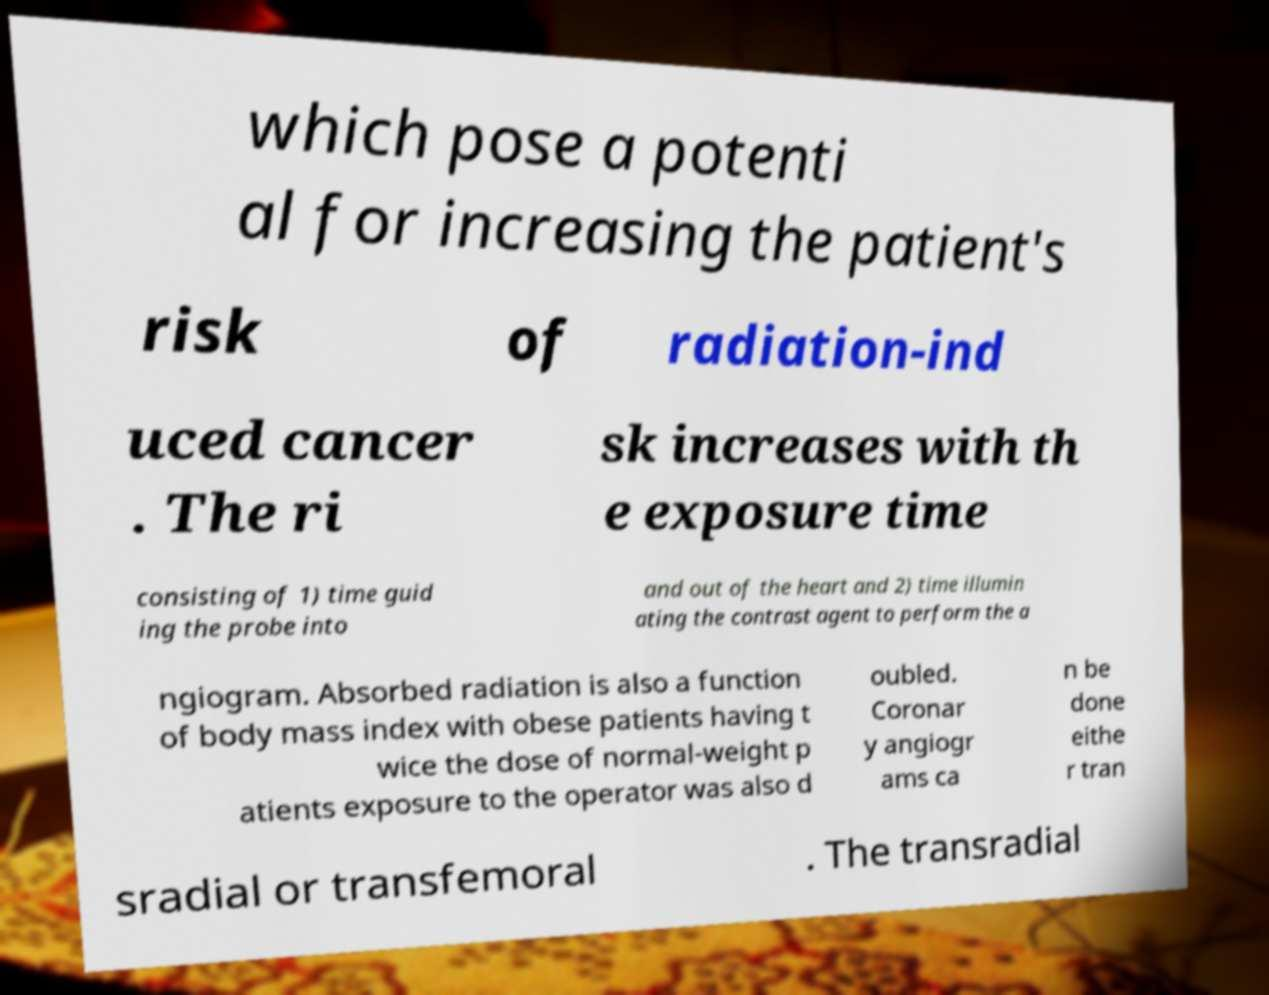What messages or text are displayed in this image? I need them in a readable, typed format. which pose a potenti al for increasing the patient's risk of radiation-ind uced cancer . The ri sk increases with th e exposure time consisting of 1) time guid ing the probe into and out of the heart and 2) time illumin ating the contrast agent to perform the a ngiogram. Absorbed radiation is also a function of body mass index with obese patients having t wice the dose of normal-weight p atients exposure to the operator was also d oubled. Coronar y angiogr ams ca n be done eithe r tran sradial or transfemoral . The transradial 